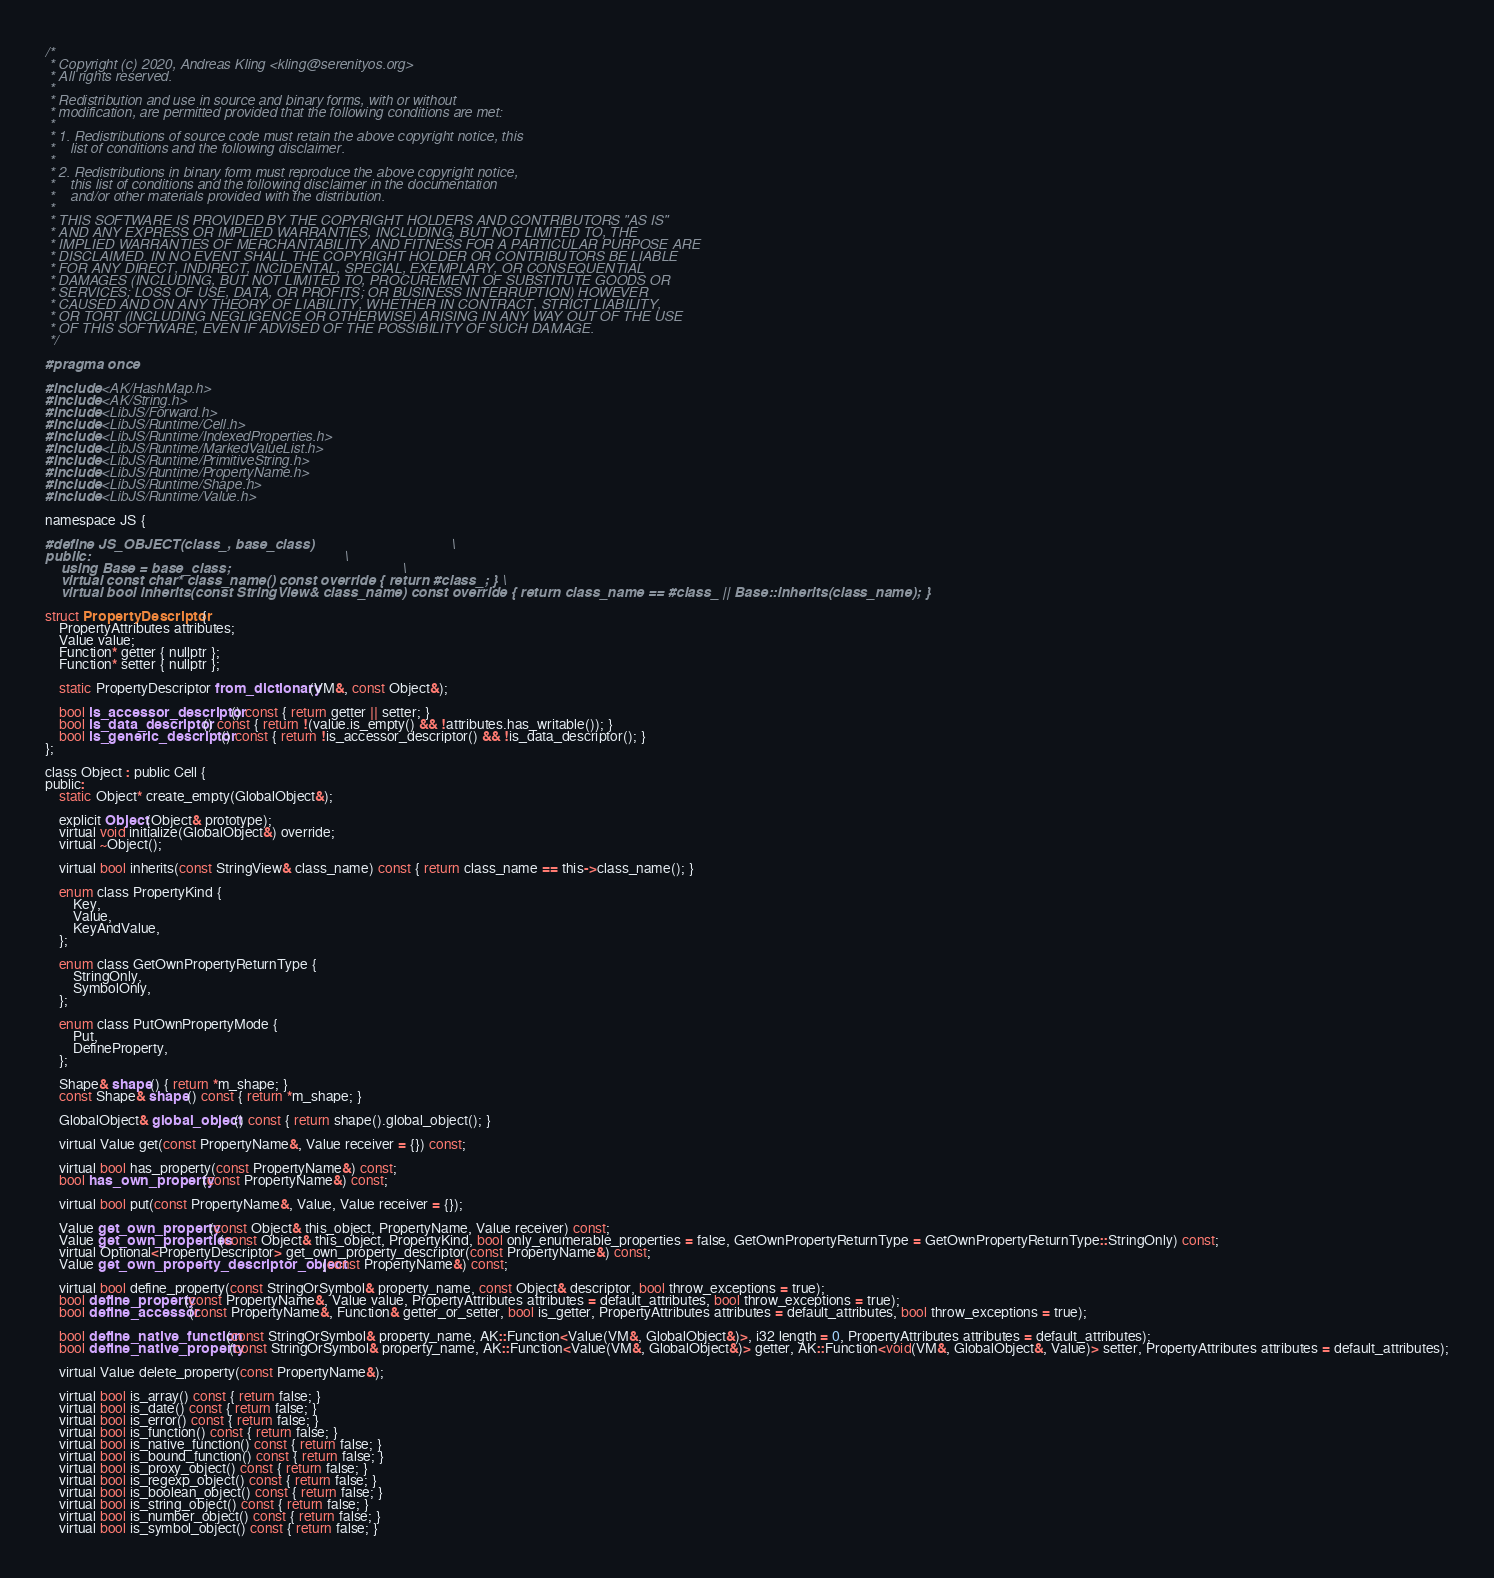Convert code to text. <code><loc_0><loc_0><loc_500><loc_500><_C_>/*
 * Copyright (c) 2020, Andreas Kling <kling@serenityos.org>
 * All rights reserved.
 *
 * Redistribution and use in source and binary forms, with or without
 * modification, are permitted provided that the following conditions are met:
 *
 * 1. Redistributions of source code must retain the above copyright notice, this
 *    list of conditions and the following disclaimer.
 *
 * 2. Redistributions in binary form must reproduce the above copyright notice,
 *    this list of conditions and the following disclaimer in the documentation
 *    and/or other materials provided with the distribution.
 *
 * THIS SOFTWARE IS PROVIDED BY THE COPYRIGHT HOLDERS AND CONTRIBUTORS "AS IS"
 * AND ANY EXPRESS OR IMPLIED WARRANTIES, INCLUDING, BUT NOT LIMITED TO, THE
 * IMPLIED WARRANTIES OF MERCHANTABILITY AND FITNESS FOR A PARTICULAR PURPOSE ARE
 * DISCLAIMED. IN NO EVENT SHALL THE COPYRIGHT HOLDER OR CONTRIBUTORS BE LIABLE
 * FOR ANY DIRECT, INDIRECT, INCIDENTAL, SPECIAL, EXEMPLARY, OR CONSEQUENTIAL
 * DAMAGES (INCLUDING, BUT NOT LIMITED TO, PROCUREMENT OF SUBSTITUTE GOODS OR
 * SERVICES; LOSS OF USE, DATA, OR PROFITS; OR BUSINESS INTERRUPTION) HOWEVER
 * CAUSED AND ON ANY THEORY OF LIABILITY, WHETHER IN CONTRACT, STRICT LIABILITY,
 * OR TORT (INCLUDING NEGLIGENCE OR OTHERWISE) ARISING IN ANY WAY OUT OF THE USE
 * OF THIS SOFTWARE, EVEN IF ADVISED OF THE POSSIBILITY OF SUCH DAMAGE.
 */

#pragma once

#include <AK/HashMap.h>
#include <AK/String.h>
#include <LibJS/Forward.h>
#include <LibJS/Runtime/Cell.h>
#include <LibJS/Runtime/IndexedProperties.h>
#include <LibJS/Runtime/MarkedValueList.h>
#include <LibJS/Runtime/PrimitiveString.h>
#include <LibJS/Runtime/PropertyName.h>
#include <LibJS/Runtime/Shape.h>
#include <LibJS/Runtime/Value.h>

namespace JS {

#define JS_OBJECT(class_, base_class)                                   \
public:                                                                 \
    using Base = base_class;                                            \
    virtual const char* class_name() const override { return #class_; } \
    virtual bool inherits(const StringView& class_name) const override { return class_name == #class_ || Base::inherits(class_name); }

struct PropertyDescriptor {
    PropertyAttributes attributes;
    Value value;
    Function* getter { nullptr };
    Function* setter { nullptr };

    static PropertyDescriptor from_dictionary(VM&, const Object&);

    bool is_accessor_descriptor() const { return getter || setter; }
    bool is_data_descriptor() const { return !(value.is_empty() && !attributes.has_writable()); }
    bool is_generic_descriptor() const { return !is_accessor_descriptor() && !is_data_descriptor(); }
};

class Object : public Cell {
public:
    static Object* create_empty(GlobalObject&);

    explicit Object(Object& prototype);
    virtual void initialize(GlobalObject&) override;
    virtual ~Object();

    virtual bool inherits(const StringView& class_name) const { return class_name == this->class_name(); }

    enum class PropertyKind {
        Key,
        Value,
        KeyAndValue,
    };

    enum class GetOwnPropertyReturnType {
        StringOnly,
        SymbolOnly,
    };

    enum class PutOwnPropertyMode {
        Put,
        DefineProperty,
    };

    Shape& shape() { return *m_shape; }
    const Shape& shape() const { return *m_shape; }

    GlobalObject& global_object() const { return shape().global_object(); }

    virtual Value get(const PropertyName&, Value receiver = {}) const;

    virtual bool has_property(const PropertyName&) const;
    bool has_own_property(const PropertyName&) const;

    virtual bool put(const PropertyName&, Value, Value receiver = {});

    Value get_own_property(const Object& this_object, PropertyName, Value receiver) const;
    Value get_own_properties(const Object& this_object, PropertyKind, bool only_enumerable_properties = false, GetOwnPropertyReturnType = GetOwnPropertyReturnType::StringOnly) const;
    virtual Optional<PropertyDescriptor> get_own_property_descriptor(const PropertyName&) const;
    Value get_own_property_descriptor_object(const PropertyName&) const;

    virtual bool define_property(const StringOrSymbol& property_name, const Object& descriptor, bool throw_exceptions = true);
    bool define_property(const PropertyName&, Value value, PropertyAttributes attributes = default_attributes, bool throw_exceptions = true);
    bool define_accessor(const PropertyName&, Function& getter_or_setter, bool is_getter, PropertyAttributes attributes = default_attributes, bool throw_exceptions = true);

    bool define_native_function(const StringOrSymbol& property_name, AK::Function<Value(VM&, GlobalObject&)>, i32 length = 0, PropertyAttributes attributes = default_attributes);
    bool define_native_property(const StringOrSymbol& property_name, AK::Function<Value(VM&, GlobalObject&)> getter, AK::Function<void(VM&, GlobalObject&, Value)> setter, PropertyAttributes attributes = default_attributes);

    virtual Value delete_property(const PropertyName&);

    virtual bool is_array() const { return false; }
    virtual bool is_date() const { return false; }
    virtual bool is_error() const { return false; }
    virtual bool is_function() const { return false; }
    virtual bool is_native_function() const { return false; }
    virtual bool is_bound_function() const { return false; }
    virtual bool is_proxy_object() const { return false; }
    virtual bool is_regexp_object() const { return false; }
    virtual bool is_boolean_object() const { return false; }
    virtual bool is_string_object() const { return false; }
    virtual bool is_number_object() const { return false; }
    virtual bool is_symbol_object() const { return false; }</code> 